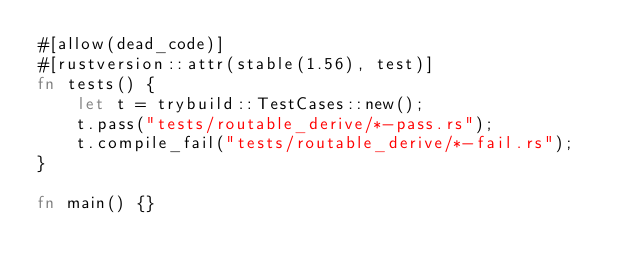<code> <loc_0><loc_0><loc_500><loc_500><_Rust_>#[allow(dead_code)]
#[rustversion::attr(stable(1.56), test)]
fn tests() {
    let t = trybuild::TestCases::new();
    t.pass("tests/routable_derive/*-pass.rs");
    t.compile_fail("tests/routable_derive/*-fail.rs");
}

fn main() {}
</code> 